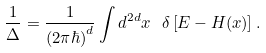Convert formula to latex. <formula><loc_0><loc_0><loc_500><loc_500>\frac { 1 } { \Delta } = \frac { 1 } { ( 2 \pi \hbar { ) } ^ { d } } \int d ^ { 2 d } x \ \delta \left [ E - H ( { x } ) \right ] .</formula> 